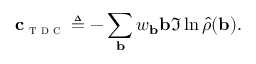<formula> <loc_0><loc_0><loc_500><loc_500>c _ { t d c } \triangle q - \sum _ { b } w _ { b } b \Im \ln \hat { \rho } ( b ) .</formula> 